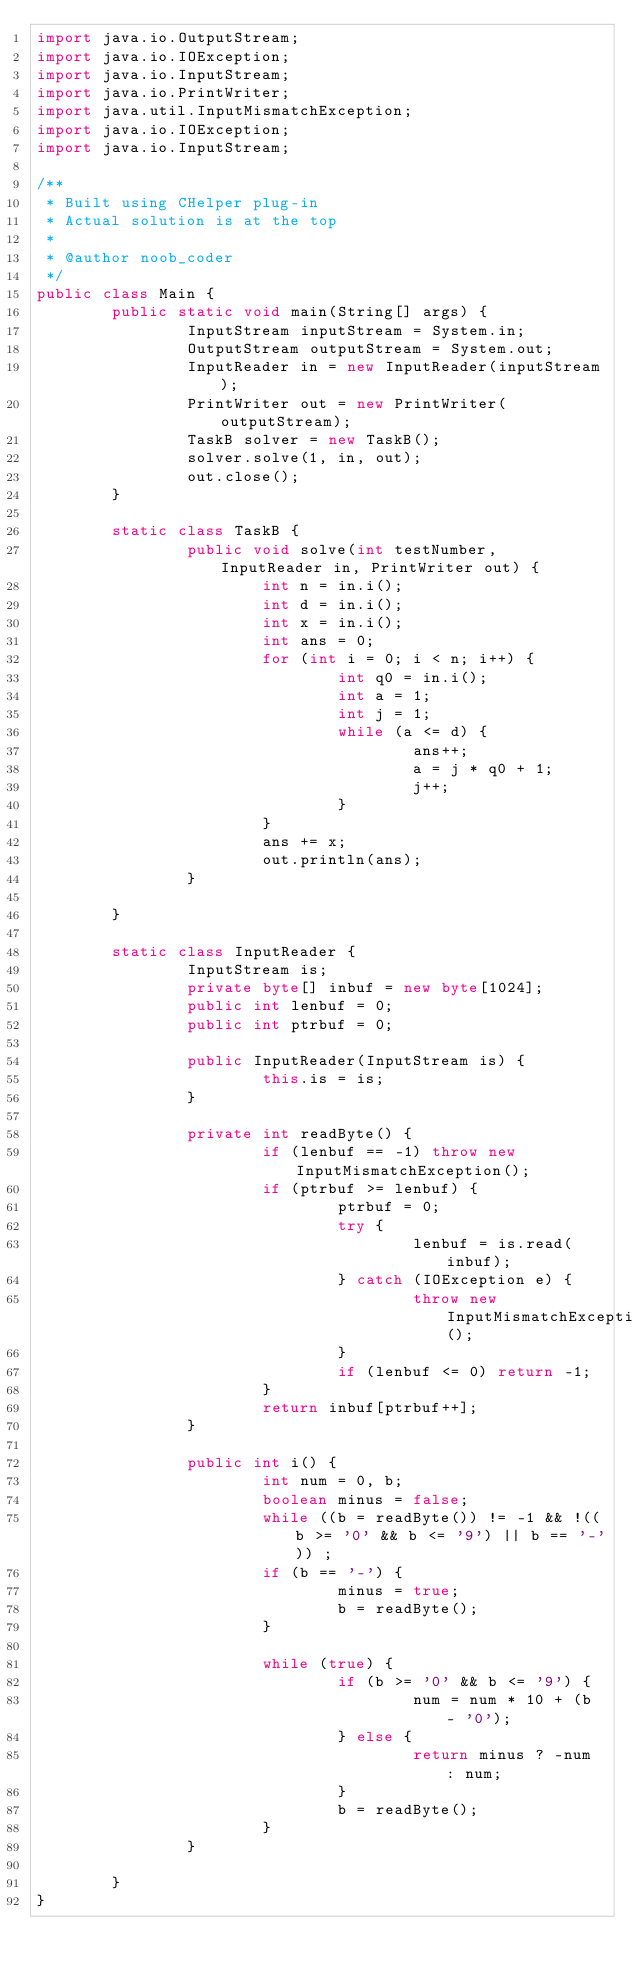Convert code to text. <code><loc_0><loc_0><loc_500><loc_500><_Java_>import java.io.OutputStream;
import java.io.IOException;
import java.io.InputStream;
import java.io.PrintWriter;
import java.util.InputMismatchException;
import java.io.IOException;
import java.io.InputStream;

/**
 * Built using CHelper plug-in
 * Actual solution is at the top
 *
 * @author noob_coder
 */
public class Main {
        public static void main(String[] args) {
                InputStream inputStream = System.in;
                OutputStream outputStream = System.out;
                InputReader in = new InputReader(inputStream);
                PrintWriter out = new PrintWriter(outputStream);
                TaskB solver = new TaskB();
                solver.solve(1, in, out);
                out.close();
        }

        static class TaskB {
                public void solve(int testNumber, InputReader in, PrintWriter out) {
                        int n = in.i();
                        int d = in.i();
                        int x = in.i();
                        int ans = 0;
                        for (int i = 0; i < n; i++) {
                                int q0 = in.i();
                                int a = 1;
                                int j = 1;
                                while (a <= d) {
                                        ans++;
                                        a = j * q0 + 1;
                                        j++;
                                }
                        }
                        ans += x;
                        out.println(ans);
                }

        }

        static class InputReader {
                InputStream is;
                private byte[] inbuf = new byte[1024];
                public int lenbuf = 0;
                public int ptrbuf = 0;

                public InputReader(InputStream is) {
                        this.is = is;
                }

                private int readByte() {
                        if (lenbuf == -1) throw new InputMismatchException();
                        if (ptrbuf >= lenbuf) {
                                ptrbuf = 0;
                                try {
                                        lenbuf = is.read(inbuf);
                                } catch (IOException e) {
                                        throw new InputMismatchException();
                                }
                                if (lenbuf <= 0) return -1;
                        }
                        return inbuf[ptrbuf++];
                }

                public int i() {
                        int num = 0, b;
                        boolean minus = false;
                        while ((b = readByte()) != -1 && !((b >= '0' && b <= '9') || b == '-')) ;
                        if (b == '-') {
                                minus = true;
                                b = readByte();
                        }

                        while (true) {
                                if (b >= '0' && b <= '9') {
                                        num = num * 10 + (b - '0');
                                } else {
                                        return minus ? -num : num;
                                }
                                b = readByte();
                        }
                }

        }
}

</code> 